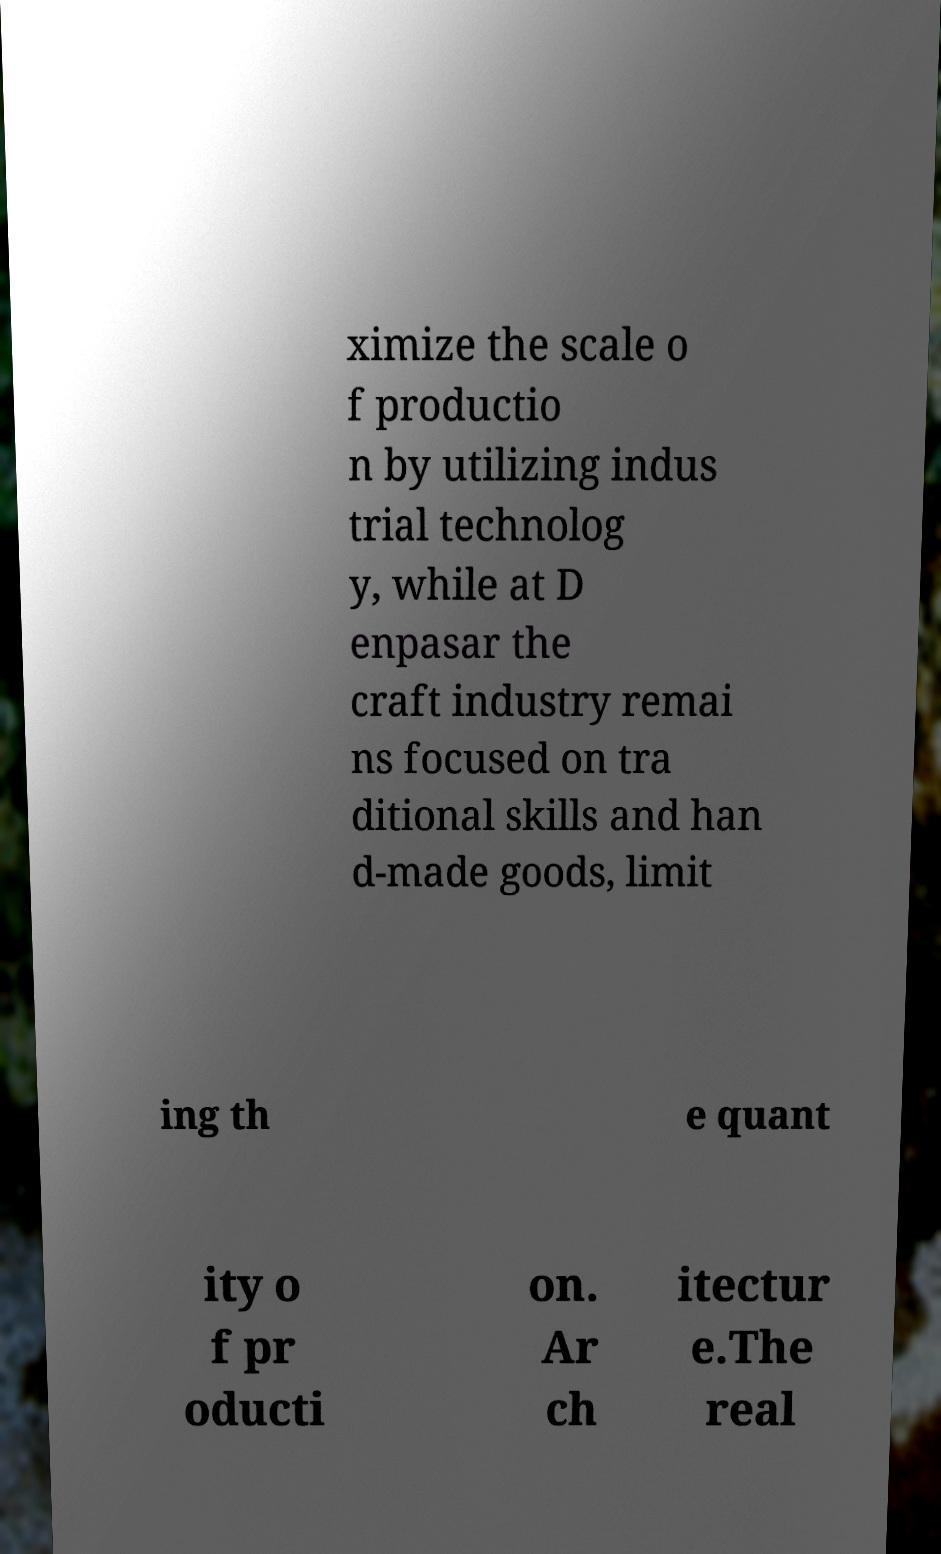Please identify and transcribe the text found in this image. ximize the scale o f productio n by utilizing indus trial technolog y, while at D enpasar the craft industry remai ns focused on tra ditional skills and han d-made goods, limit ing th e quant ity o f pr oducti on. Ar ch itectur e.The real 